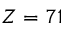Convert formula to latex. <formula><loc_0><loc_0><loc_500><loc_500>Z = 7 1</formula> 